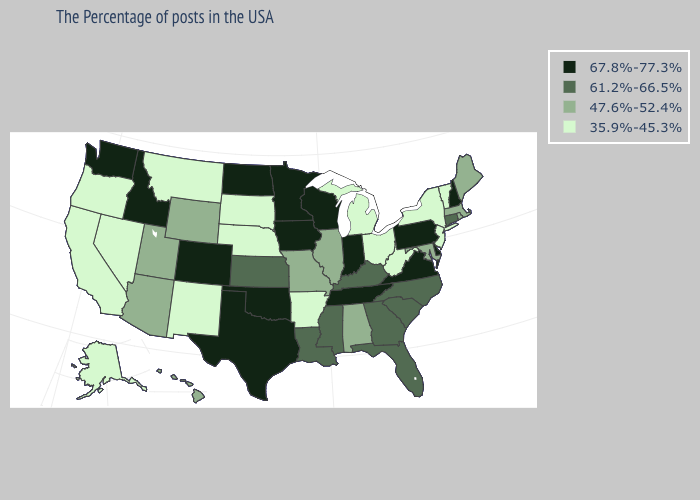Among the states that border Montana , which have the lowest value?
Be succinct. South Dakota. What is the value of Minnesota?
Keep it brief. 67.8%-77.3%. Which states have the highest value in the USA?
Give a very brief answer. New Hampshire, Delaware, Pennsylvania, Virginia, Indiana, Tennessee, Wisconsin, Minnesota, Iowa, Oklahoma, Texas, North Dakota, Colorado, Idaho, Washington. Which states have the lowest value in the South?
Quick response, please. West Virginia, Arkansas. What is the value of California?
Answer briefly. 35.9%-45.3%. What is the lowest value in states that border Nebraska?
Write a very short answer. 35.9%-45.3%. Name the states that have a value in the range 47.6%-52.4%?
Write a very short answer. Maine, Massachusetts, Rhode Island, Maryland, Alabama, Illinois, Missouri, Wyoming, Utah, Arizona, Hawaii. Does the map have missing data?
Give a very brief answer. No. Name the states that have a value in the range 35.9%-45.3%?
Short answer required. Vermont, New York, New Jersey, West Virginia, Ohio, Michigan, Arkansas, Nebraska, South Dakota, New Mexico, Montana, Nevada, California, Oregon, Alaska. Name the states that have a value in the range 61.2%-66.5%?
Concise answer only. Connecticut, North Carolina, South Carolina, Florida, Georgia, Kentucky, Mississippi, Louisiana, Kansas. Does Washington have a lower value than New Mexico?
Be succinct. No. What is the lowest value in states that border Louisiana?
Concise answer only. 35.9%-45.3%. Name the states that have a value in the range 67.8%-77.3%?
Write a very short answer. New Hampshire, Delaware, Pennsylvania, Virginia, Indiana, Tennessee, Wisconsin, Minnesota, Iowa, Oklahoma, Texas, North Dakota, Colorado, Idaho, Washington. Does Oregon have the highest value in the USA?
Quick response, please. No. 